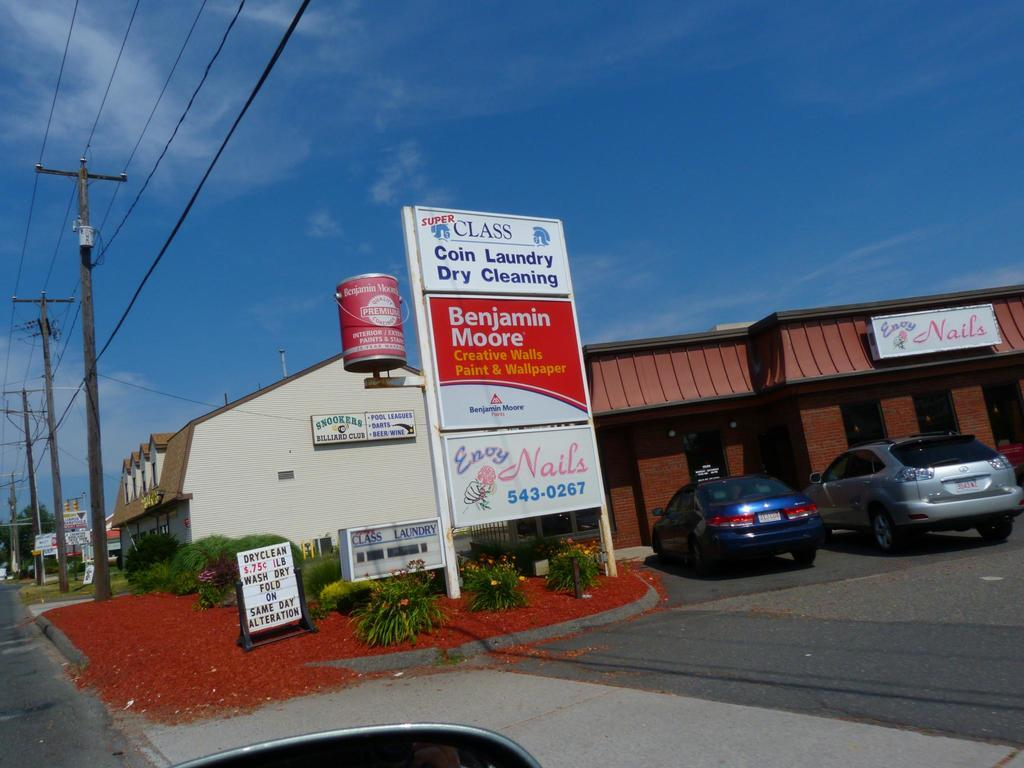<image>
Summarize the visual content of the image. A nail salon shares a sign with the Benjamin Moore paint store. 